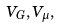<formula> <loc_0><loc_0><loc_500><loc_500>V _ { G } , V _ { \mu } ,</formula> 